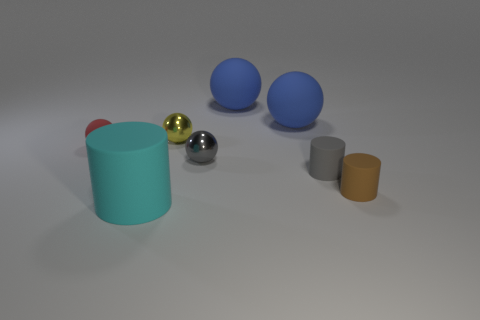What material is the large object that is in front of the tiny shiny object that is in front of the rubber object to the left of the large cyan rubber thing?
Give a very brief answer. Rubber. Is there anything else that is the same material as the tiny yellow object?
Ensure brevity in your answer.  Yes. Does the brown rubber object have the same size as the cyan thing that is in front of the small gray rubber cylinder?
Provide a short and direct response. No. What number of things are rubber things on the right side of the gray cylinder or rubber things that are in front of the small red matte object?
Offer a terse response. 3. There is a tiny cylinder on the left side of the brown rubber object; what color is it?
Keep it short and to the point. Gray. There is a small matte cylinder that is on the left side of the brown object; are there any brown matte objects that are left of it?
Your answer should be compact. No. Are there fewer large purple metallic cubes than large rubber things?
Your answer should be compact. Yes. There is a cylinder that is in front of the tiny brown object that is in front of the gray metal sphere; what is it made of?
Offer a terse response. Rubber. Is the red object the same size as the cyan rubber object?
Provide a succinct answer. No. How many things are red rubber objects or gray things?
Your response must be concise. 3. 